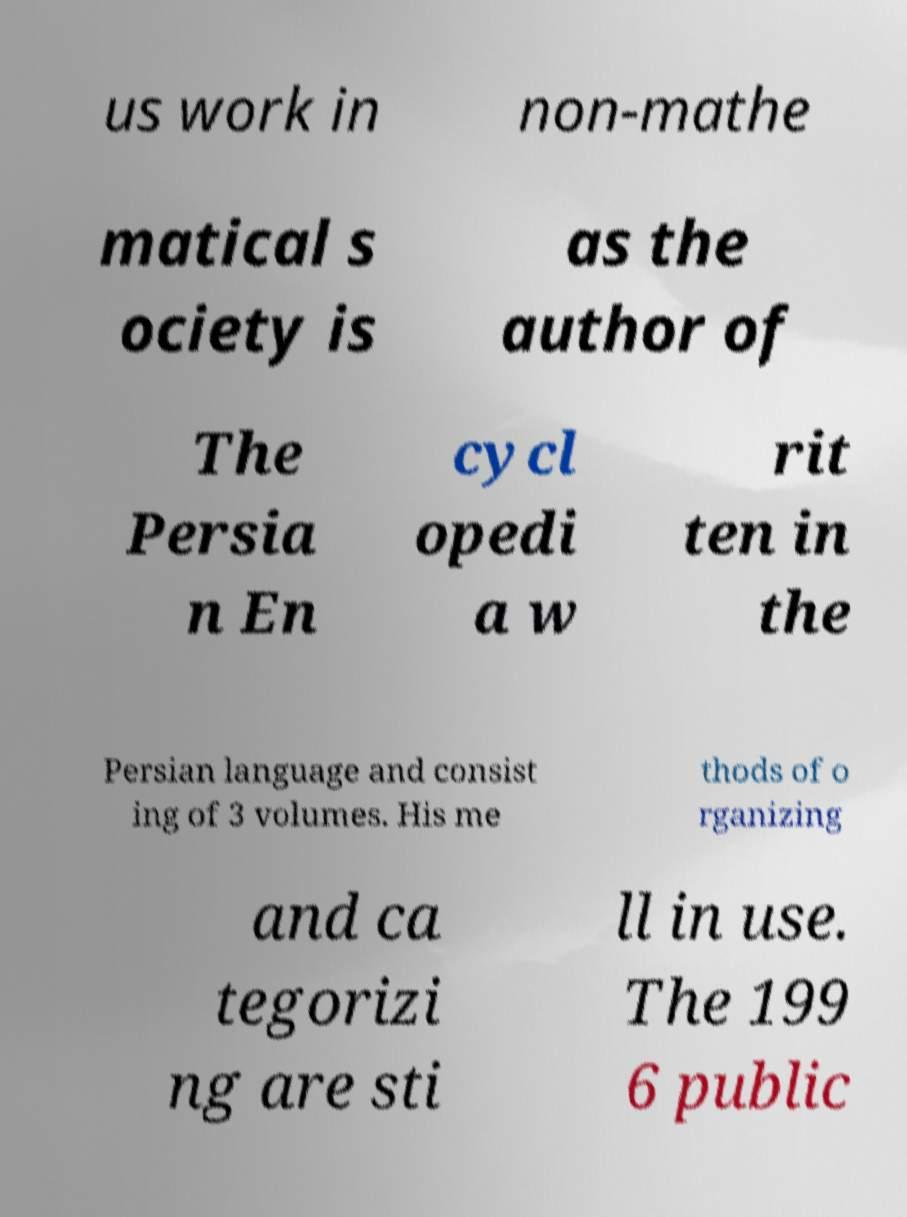Please identify and transcribe the text found in this image. us work in non-mathe matical s ociety is as the author of The Persia n En cycl opedi a w rit ten in the Persian language and consist ing of 3 volumes. His me thods of o rganizing and ca tegorizi ng are sti ll in use. The 199 6 public 